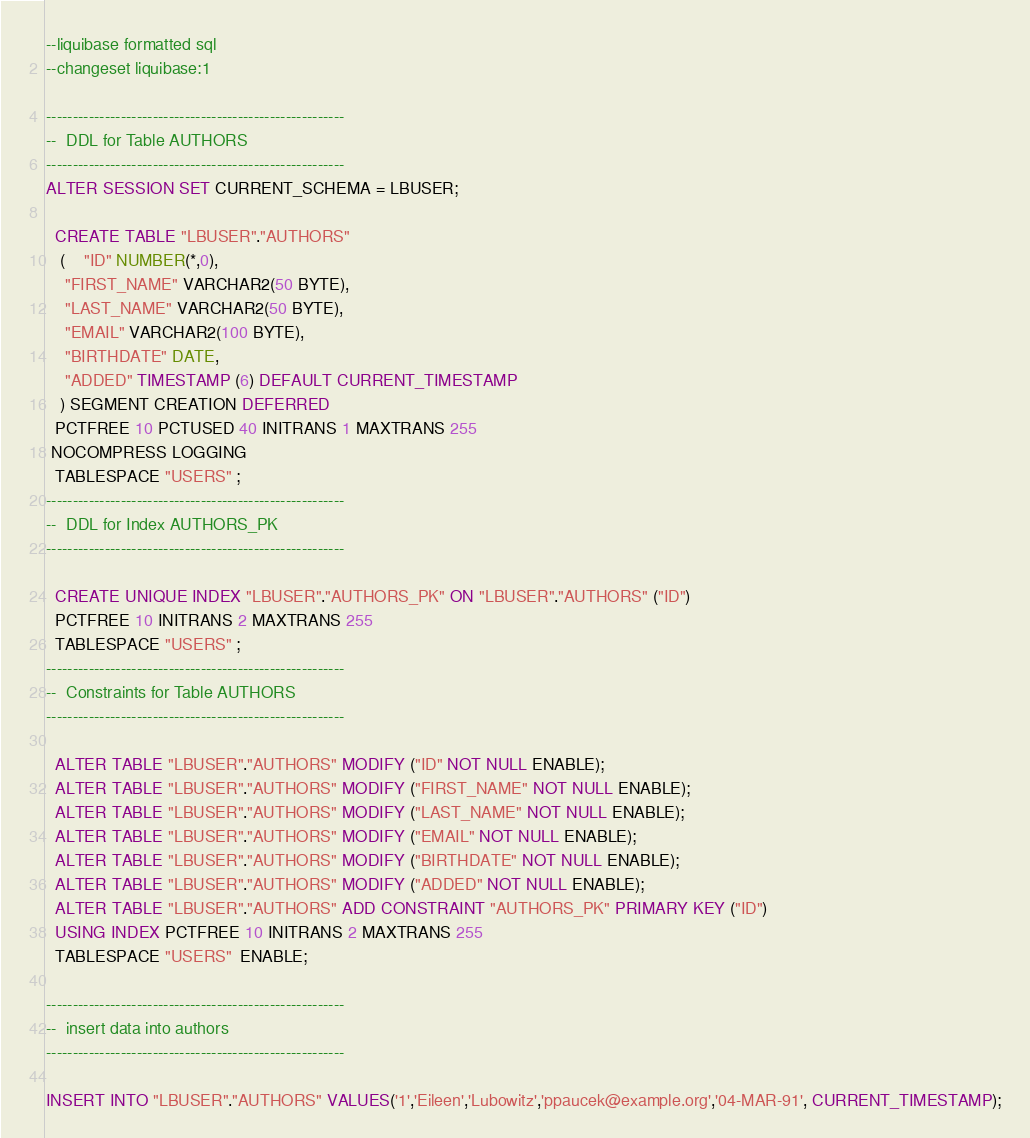<code> <loc_0><loc_0><loc_500><loc_500><_SQL_>--liquibase formatted sql
--changeset liquibase:1

--------------------------------------------------------
--  DDL for Table AUTHORS
--------------------------------------------------------
ALTER SESSION SET CURRENT_SCHEMA = LBUSER;

  CREATE TABLE "LBUSER"."AUTHORS" 
   (	"ID" NUMBER(*,0), 
	"FIRST_NAME" VARCHAR2(50 BYTE), 
	"LAST_NAME" VARCHAR2(50 BYTE), 
	"EMAIL" VARCHAR2(100 BYTE), 
	"BIRTHDATE" DATE, 
	"ADDED" TIMESTAMP (6) DEFAULT CURRENT_TIMESTAMP
   ) SEGMENT CREATION DEFERRED 
  PCTFREE 10 PCTUSED 40 INITRANS 1 MAXTRANS 255 
 NOCOMPRESS LOGGING
  TABLESPACE "USERS" ;
--------------------------------------------------------
--  DDL for Index AUTHORS_PK
--------------------------------------------------------

  CREATE UNIQUE INDEX "LBUSER"."AUTHORS_PK" ON "LBUSER"."AUTHORS" ("ID") 
  PCTFREE 10 INITRANS 2 MAXTRANS 255 
  TABLESPACE "USERS" ;
--------------------------------------------------------
--  Constraints for Table AUTHORS
--------------------------------------------------------

  ALTER TABLE "LBUSER"."AUTHORS" MODIFY ("ID" NOT NULL ENABLE);
  ALTER TABLE "LBUSER"."AUTHORS" MODIFY ("FIRST_NAME" NOT NULL ENABLE);
  ALTER TABLE "LBUSER"."AUTHORS" MODIFY ("LAST_NAME" NOT NULL ENABLE);
  ALTER TABLE "LBUSER"."AUTHORS" MODIFY ("EMAIL" NOT NULL ENABLE);
  ALTER TABLE "LBUSER"."AUTHORS" MODIFY ("BIRTHDATE" NOT NULL ENABLE);
  ALTER TABLE "LBUSER"."AUTHORS" MODIFY ("ADDED" NOT NULL ENABLE);
  ALTER TABLE "LBUSER"."AUTHORS" ADD CONSTRAINT "AUTHORS_PK" PRIMARY KEY ("ID")
  USING INDEX PCTFREE 10 INITRANS 2 MAXTRANS 255 
  TABLESPACE "USERS"  ENABLE;

--------------------------------------------------------
--  insert data into authors
--------------------------------------------------------

INSERT INTO "LBUSER"."AUTHORS" VALUES('1','Eileen','Lubowitz','ppaucek@example.org','04-MAR-91', CURRENT_TIMESTAMP);</code> 